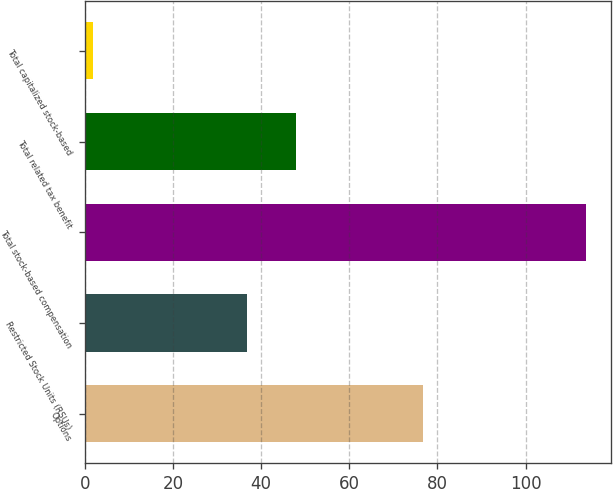Convert chart to OTSL. <chart><loc_0><loc_0><loc_500><loc_500><bar_chart><fcel>Options<fcel>Restricted Stock Units (RSUs)<fcel>Total stock-based compensation<fcel>Total related tax benefit<fcel>Total capitalized stock-based<nl><fcel>76.8<fcel>36.8<fcel>113.6<fcel>47.97<fcel>1.9<nl></chart> 